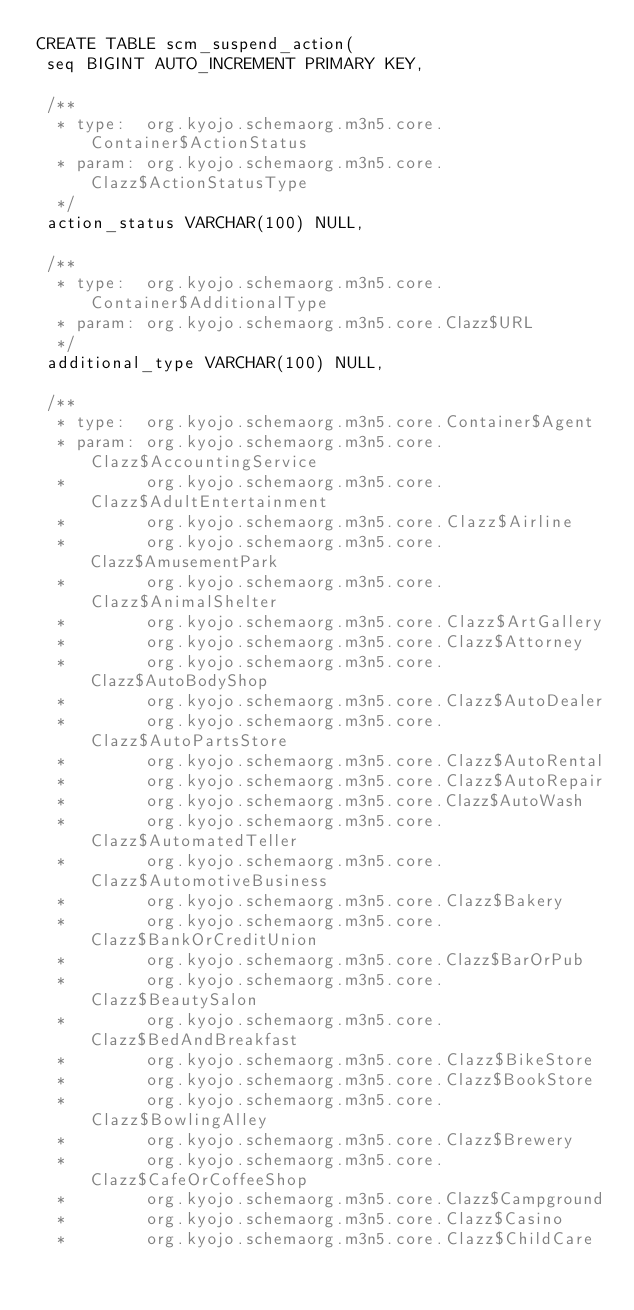Convert code to text. <code><loc_0><loc_0><loc_500><loc_500><_SQL_>CREATE TABLE scm_suspend_action(
 seq BIGINT AUTO_INCREMENT PRIMARY KEY,

 /**
  * type:  org.kyojo.schemaorg.m3n5.core.Container$ActionStatus
  * param: org.kyojo.schemaorg.m3n5.core.Clazz$ActionStatusType
  */
 action_status VARCHAR(100) NULL,

 /**
  * type:  org.kyojo.schemaorg.m3n5.core.Container$AdditionalType
  * param: org.kyojo.schemaorg.m3n5.core.Clazz$URL
  */
 additional_type VARCHAR(100) NULL,

 /**
  * type:  org.kyojo.schemaorg.m3n5.core.Container$Agent
  * param: org.kyojo.schemaorg.m3n5.core.Clazz$AccountingService
  *        org.kyojo.schemaorg.m3n5.core.Clazz$AdultEntertainment
  *        org.kyojo.schemaorg.m3n5.core.Clazz$Airline
  *        org.kyojo.schemaorg.m3n5.core.Clazz$AmusementPark
  *        org.kyojo.schemaorg.m3n5.core.Clazz$AnimalShelter
  *        org.kyojo.schemaorg.m3n5.core.Clazz$ArtGallery
  *        org.kyojo.schemaorg.m3n5.core.Clazz$Attorney
  *        org.kyojo.schemaorg.m3n5.core.Clazz$AutoBodyShop
  *        org.kyojo.schemaorg.m3n5.core.Clazz$AutoDealer
  *        org.kyojo.schemaorg.m3n5.core.Clazz$AutoPartsStore
  *        org.kyojo.schemaorg.m3n5.core.Clazz$AutoRental
  *        org.kyojo.schemaorg.m3n5.core.Clazz$AutoRepair
  *        org.kyojo.schemaorg.m3n5.core.Clazz$AutoWash
  *        org.kyojo.schemaorg.m3n5.core.Clazz$AutomatedTeller
  *        org.kyojo.schemaorg.m3n5.core.Clazz$AutomotiveBusiness
  *        org.kyojo.schemaorg.m3n5.core.Clazz$Bakery
  *        org.kyojo.schemaorg.m3n5.core.Clazz$BankOrCreditUnion
  *        org.kyojo.schemaorg.m3n5.core.Clazz$BarOrPub
  *        org.kyojo.schemaorg.m3n5.core.Clazz$BeautySalon
  *        org.kyojo.schemaorg.m3n5.core.Clazz$BedAndBreakfast
  *        org.kyojo.schemaorg.m3n5.core.Clazz$BikeStore
  *        org.kyojo.schemaorg.m3n5.core.Clazz$BookStore
  *        org.kyojo.schemaorg.m3n5.core.Clazz$BowlingAlley
  *        org.kyojo.schemaorg.m3n5.core.Clazz$Brewery
  *        org.kyojo.schemaorg.m3n5.core.Clazz$CafeOrCoffeeShop
  *        org.kyojo.schemaorg.m3n5.core.Clazz$Campground
  *        org.kyojo.schemaorg.m3n5.core.Clazz$Casino
  *        org.kyojo.schemaorg.m3n5.core.Clazz$ChildCare</code> 